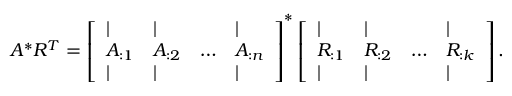Convert formula to latex. <formula><loc_0><loc_0><loc_500><loc_500>A ^ { * } R ^ { T } = \left [ \begin{array} { l l l l } { | } & { | } & & { | } \\ { A _ { \colon 1 } } & { A _ { \colon 2 } } & { \dots } & { A _ { \colon n } } \\ { | } & { | } & & { | } \end{array} \right ] ^ { * } \left [ \begin{array} { l l l l } { | } & { | } & & { | } \\ { R _ { \colon 1 } } & { R _ { \colon 2 } } & { \dots } & { R _ { \colon k } } \\ { | } & { | } & & { | } \end{array} \right ] .</formula> 